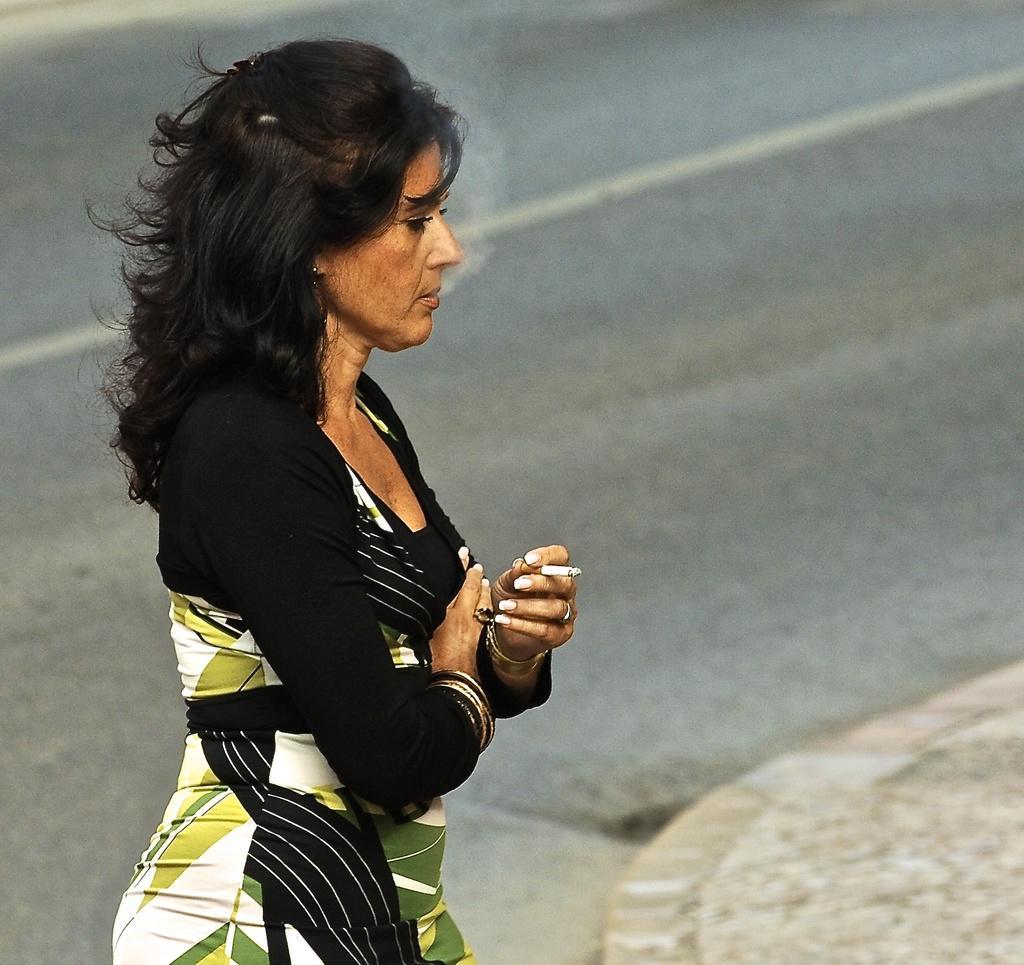Could you give a brief overview of what you see in this image? In this image we can see a woman standing and smoking, also we can see the road. 